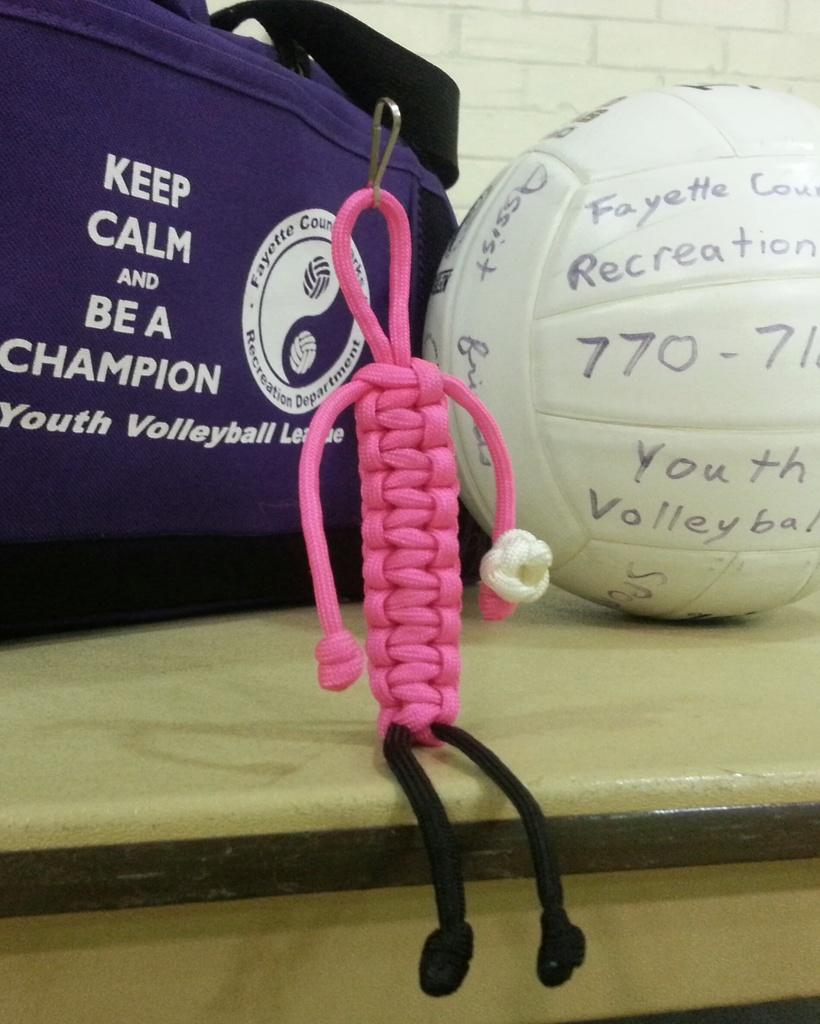What object can be seen in the image that is typically used for playing games? There is a ball in the image that is typically used for playing games. What object in the image is commonly used for carrying items? There is a bag in the image that is commonly used for carrying items. What type of structure is visible in the image? There is a wall in the image. What activity is being performed in the image? Thread crafting is present in the image. What type of furniture is visible in the image? There is a table in the image. What is written on the ball in the image? Something is written on the ball in the image. What is written on the bag in the image? Something is written on the bag in the image. How much honey is being used in the thread crafting activity in the image? There is no honey present in the image, and it is not mentioned in the provided facts. 